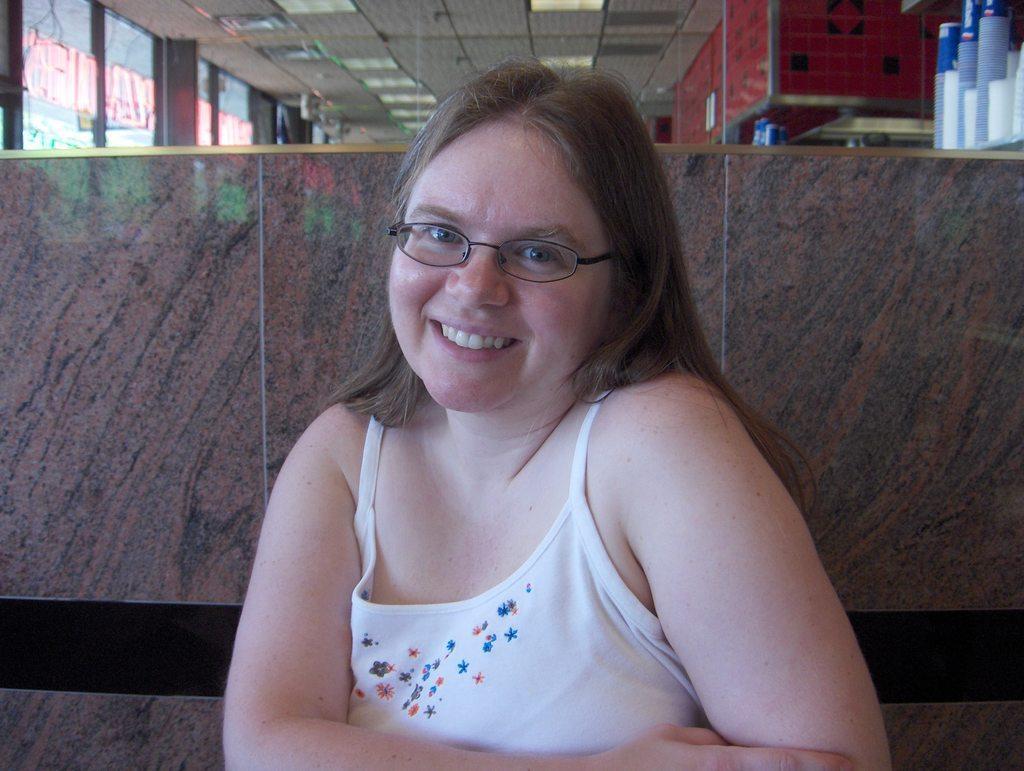How would you summarize this image in a sentence or two? In this picture we can see a woman smiling, at the right top there are some glasses, in the background we can see glass, there are some lights at the top of the picture. 